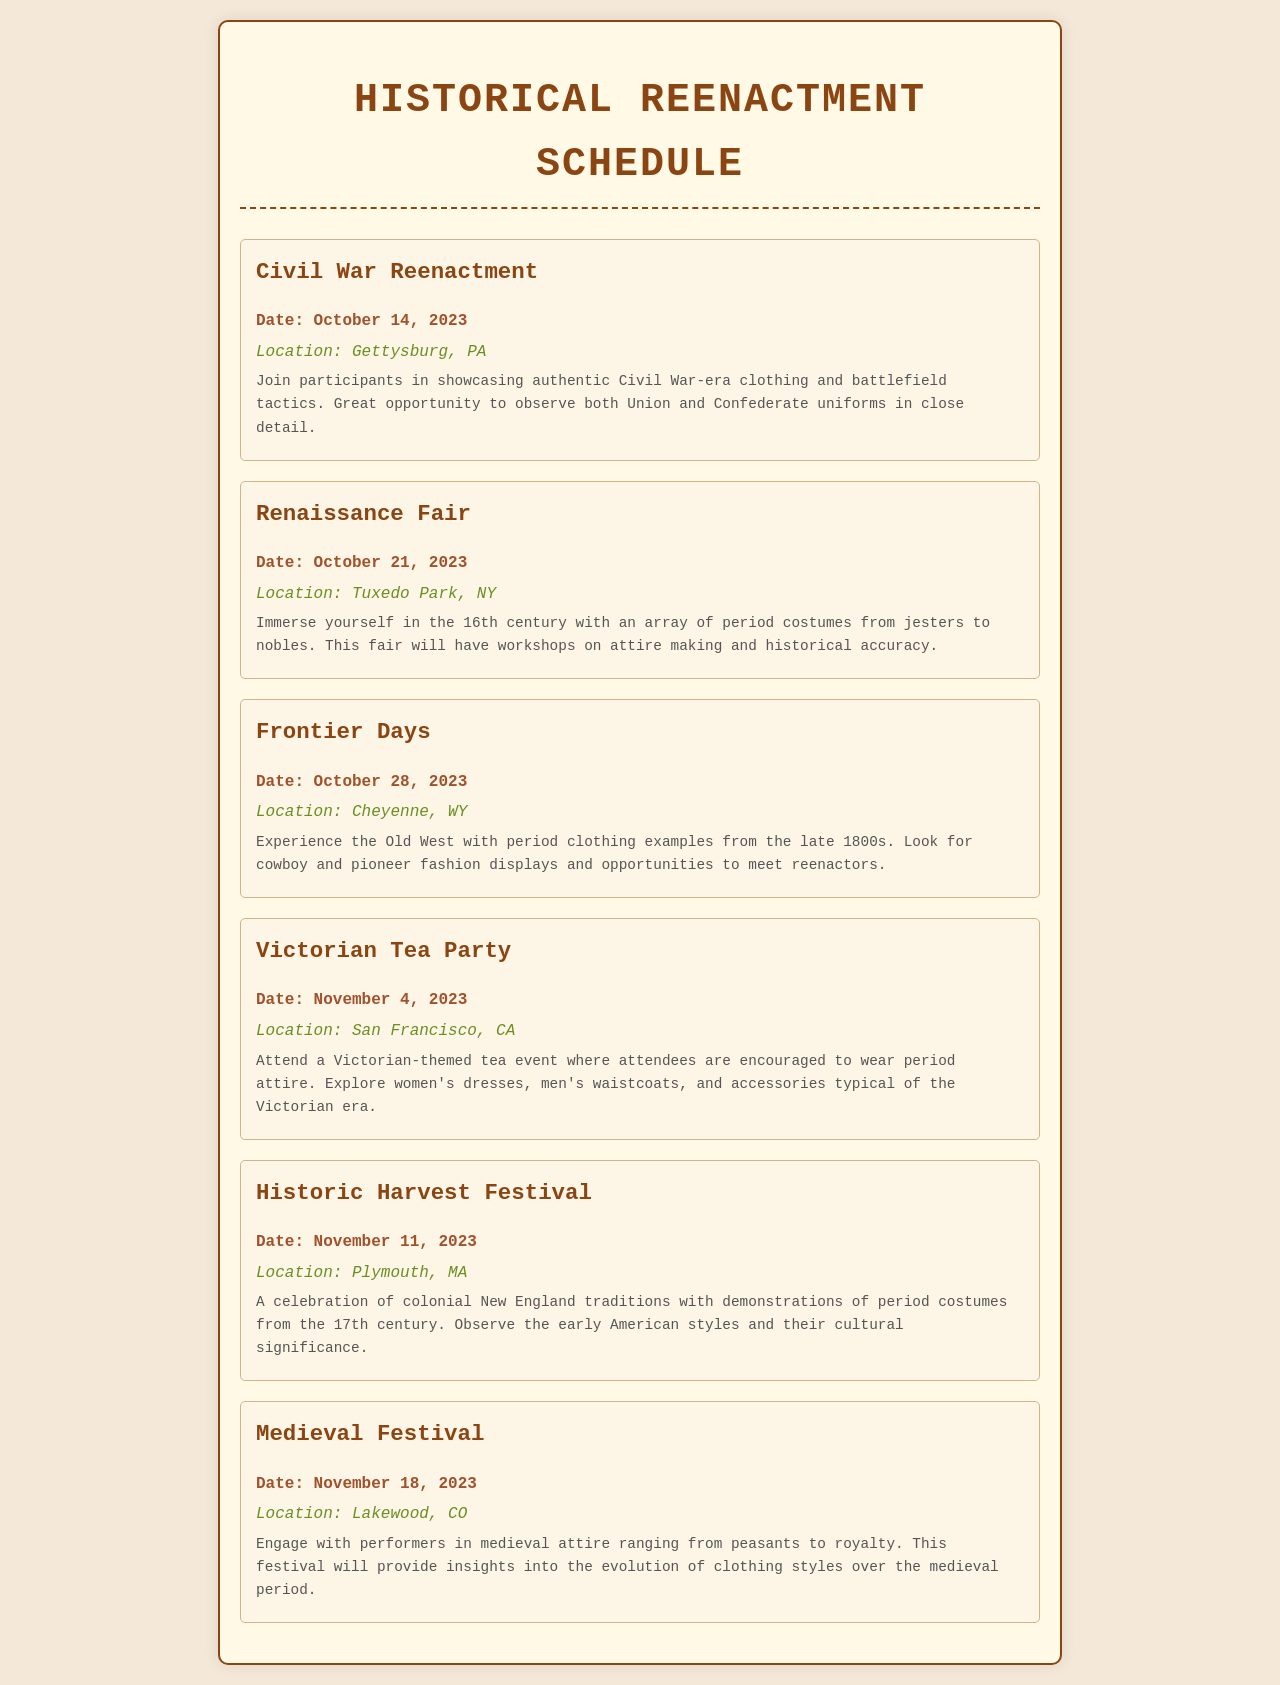What is the date of the Civil War Reenactment? The document specifies the date listed for the Civil War Reenactment as October 14, 2023.
Answer: October 14, 2023 Where is the Renaissance Fair taking place? The location provided in the document for the Renaissance Fair is Tuxedo Park, NY.
Answer: Tuxedo Park, NY What type of event is scheduled on November 4, 2023? The document describes the event on this date as a Victorian Tea Party, indicating its theme.
Answer: Victorian Tea Party How many events are scheduled in October 2023? Counting the events listed for October in the document, there are three events: Civil War Reenactment, Renaissance Fair, and Frontier Days.
Answer: 3 Which historical period does the Historic Harvest Festival focus on? According to the document, the Historic Harvest Festival centers on colonial New England traditions, indicating a focus on the 17th century.
Answer: 17th century What is the theme of the Medieval Festival? The document states that the theme of the Medieval Festival involves performers in medieval attire.
Answer: Medieval attire Which state is hosting the Frontier Days event? The location of the Frontier Days event, as noted in the document, is Cheyenne, WY, indicating the corresponding state.
Answer: Wyoming What are participants encouraged to wear at the Victorian Tea Party? The document indicates that attendees at the Victorian Tea Party are encouraged to wear period attire.
Answer: Period attire 